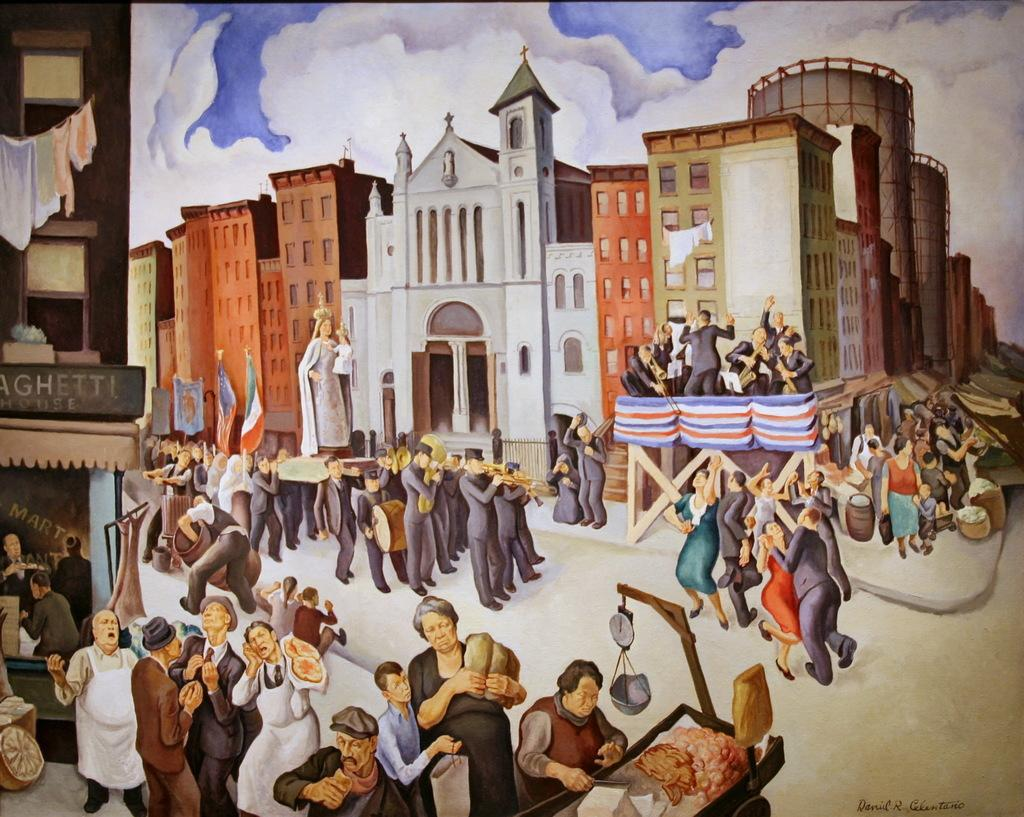What type of artwork is depicted in the image? The image is a painting. What is happening in the middle of the painting? There are people walking on a road in the middle of the painting. Where are the people located on the left side of the painting? There are people standing on the left side of the painting. What structures can be seen in the painting? There are buildings visible in the painting. What is visible at the top of the painting? The sky is visible at the top of the painting. What type of mass is being held at night in the painting? There is no mass or nighttime setting depicted in the painting; it features people walking on a road and standing on the left side, with buildings and the sky visible. 